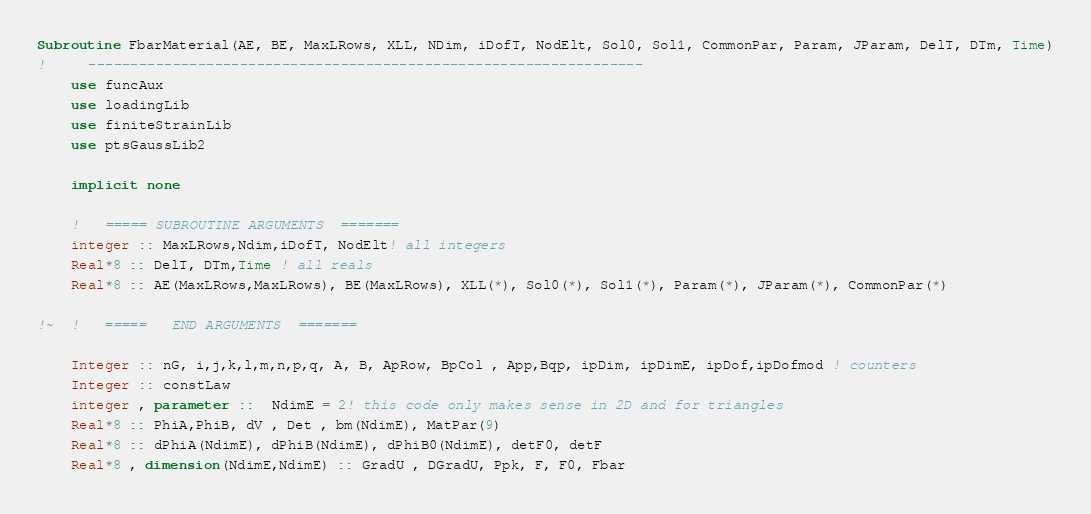Convert code to text. <code><loc_0><loc_0><loc_500><loc_500><_FORTRAN_>Subroutine FbarMaterial(AE, BE, MaxLRows, XLL, NDim, iDofT, NodElt, Sol0, Sol1, CommonPar, Param, JParam, DelT, DTm, Time)
!     ------------------------------------------------------------------
	use funcAux
	use loadingLib
	use finiteStrainLib
	use ptsGaussLib2
	
	implicit none

	!   ===== SUBROUTINE ARGUMENTS  =======
	integer :: MaxLRows,Ndim,iDofT, NodElt! all integers
	Real*8 :: DelT, DTm,Time ! all reals
	Real*8 :: AE(MaxLRows,MaxLRows), BE(MaxLRows), XLL(*), Sol0(*), Sol1(*), Param(*), JParam(*), CommonPar(*)

!~ 	!   =====   END ARGUMENTS  =======
         
	Integer :: nG, i,j,k,l,m,n,p,q, A, B, ApRow, BpCol , App,Bqp, ipDim, ipDimE, ipDof,ipDofmod ! counters 
	Integer :: constLaw 
	integer , parameter ::  NdimE = 2! this code only makes sense in 2D and for triangles 
	Real*8 :: PhiA,PhiB, dV , Det , bm(NdimE), MatPar(9)
	Real*8 :: dPhiA(NdimE), dPhiB(NdimE), dPhiB0(NdimE), detF0, detF
	Real*8 , dimension(NdimE,NdimE) :: GradU , DGradU, Ppk, F, F0, Fbar</code> 